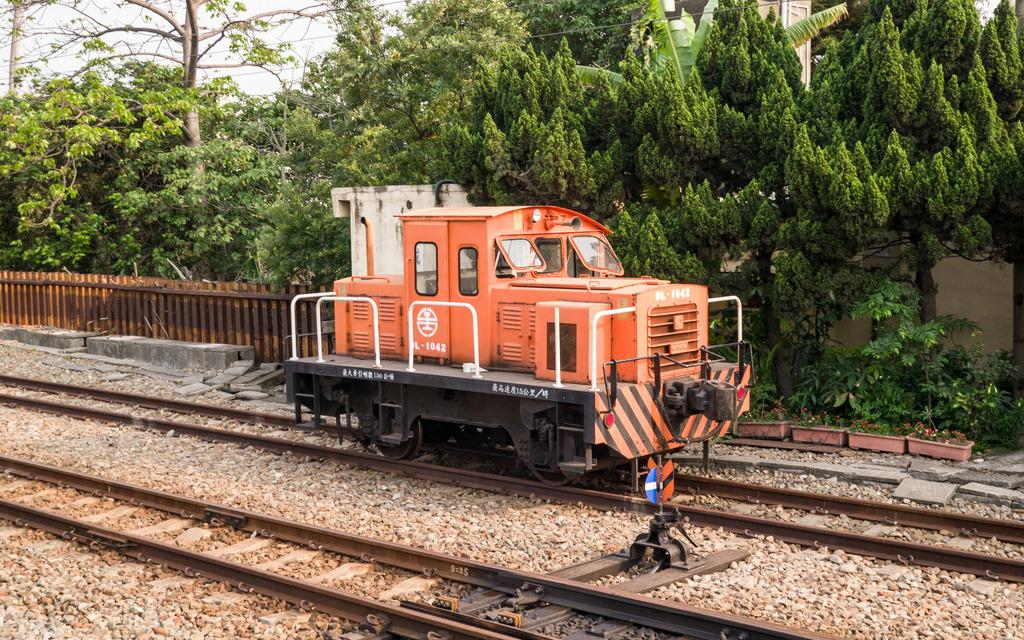What type of transportation infrastructure is present in the image? There are railway tracks in the image. What can be seen traveling along the railway tracks? There is an orange-colored train engine in the image. What natural elements are visible in the background of the image? There are trees visible in the background of the image. What type of gardening tool is being used by the train engine in the image? There is no gardening tool, such as a spade, present in the image. The train engine is not using any tool for gardening purposes. 